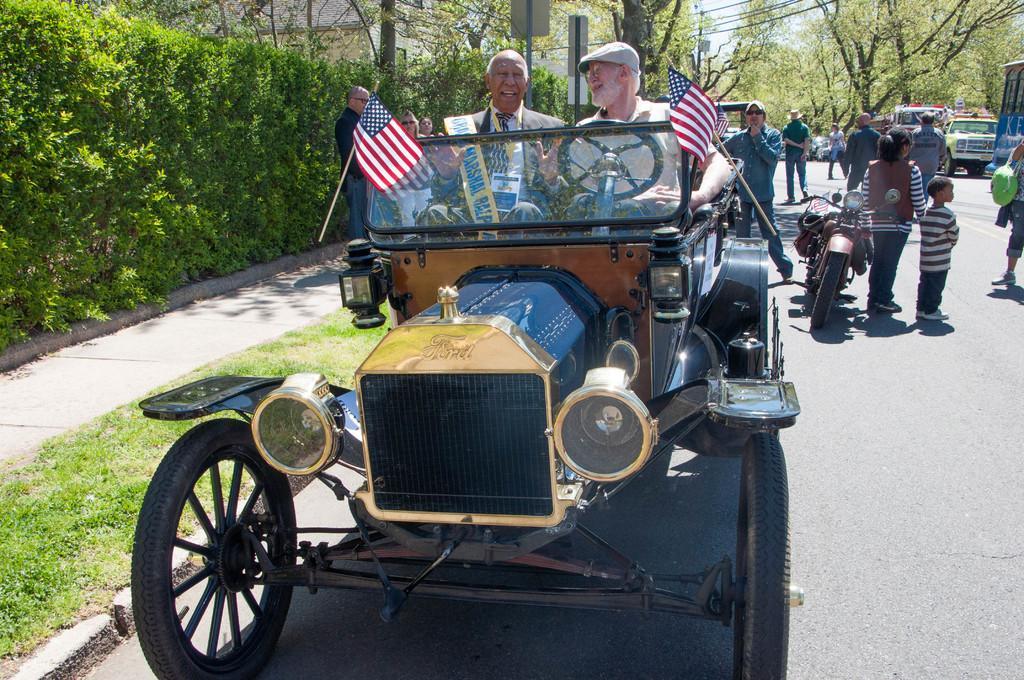Describe this image in one or two sentences. In the middle of the image there is a vehicle on the vehicle two people are sitting and smiling. Top right side of the image there is a tree and there are some vehicles and there are some group of people walking. In the middle of the image there is a bike. Top left side of the image there are some bushes. Bottom left side of the image there is grass. 